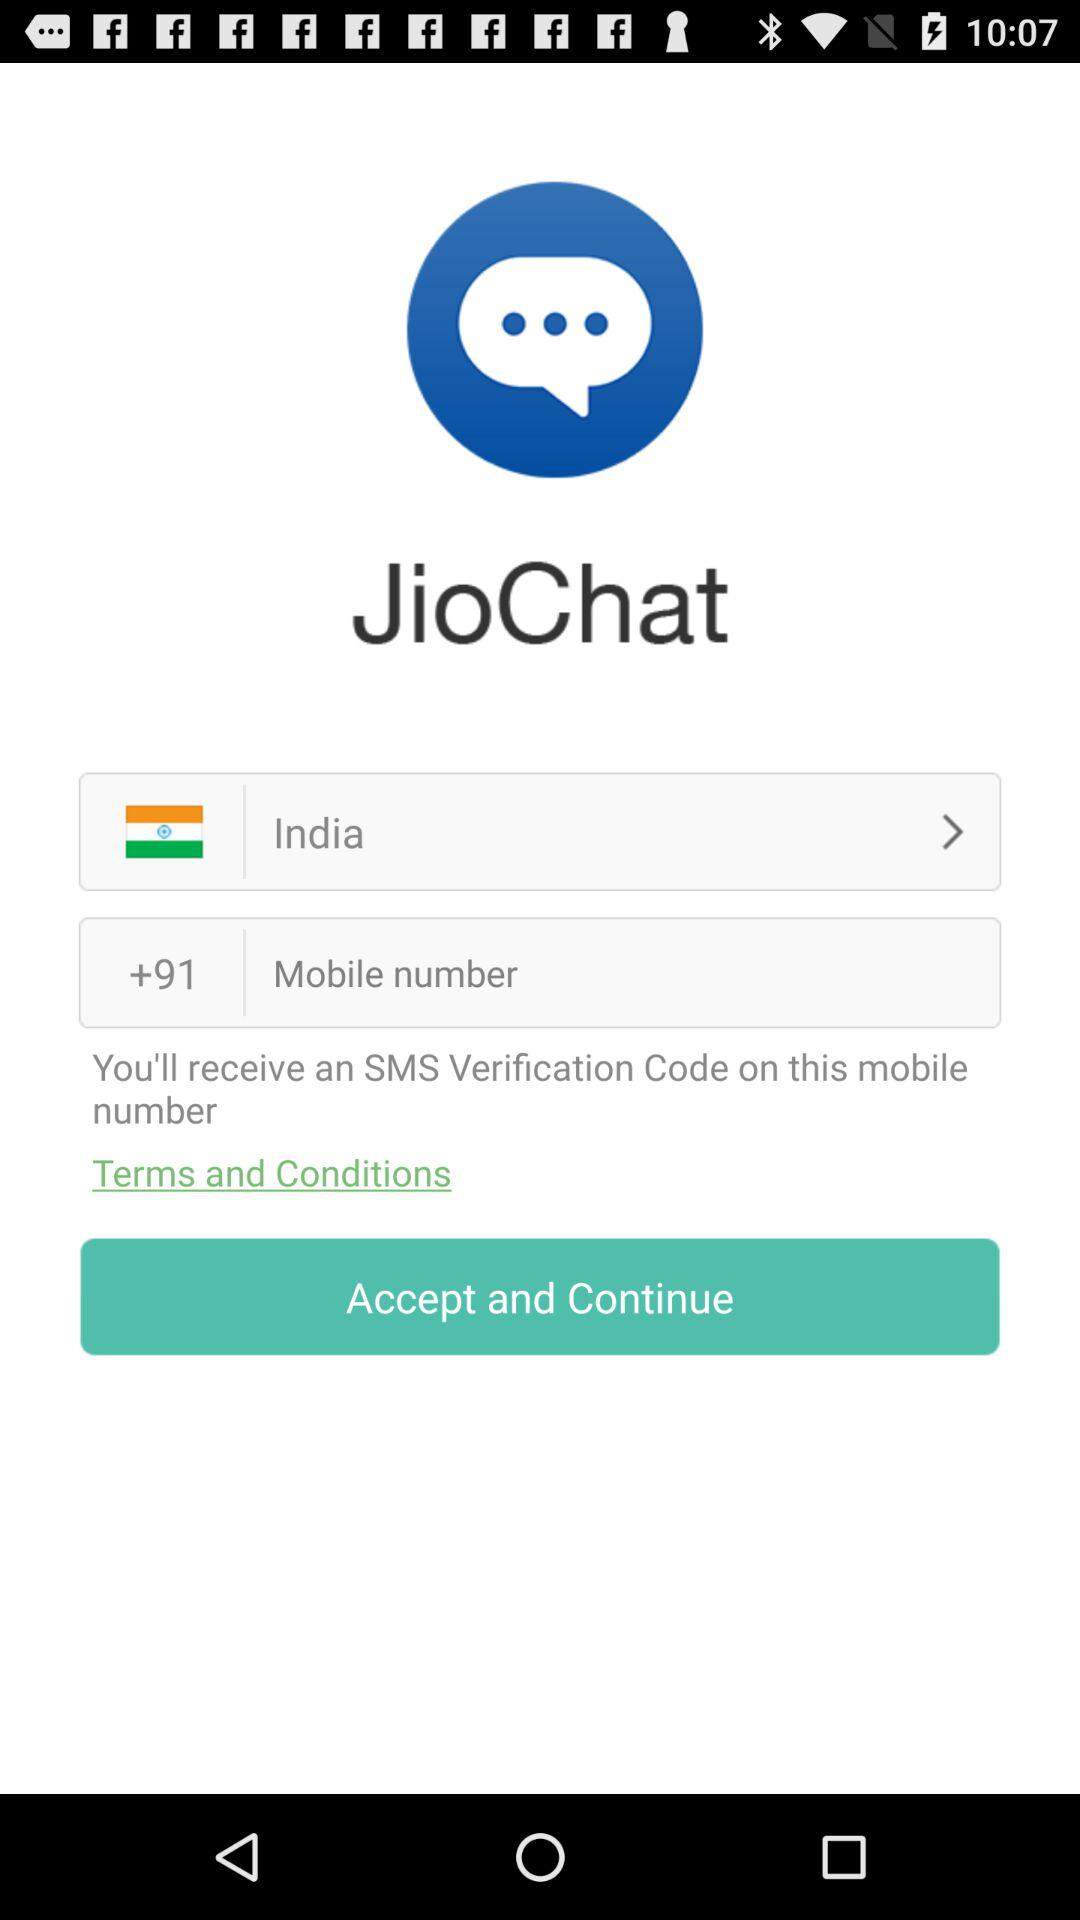How many text fields do you have to fill out to create a JioChat account?
Answer the question using a single word or phrase. 2 